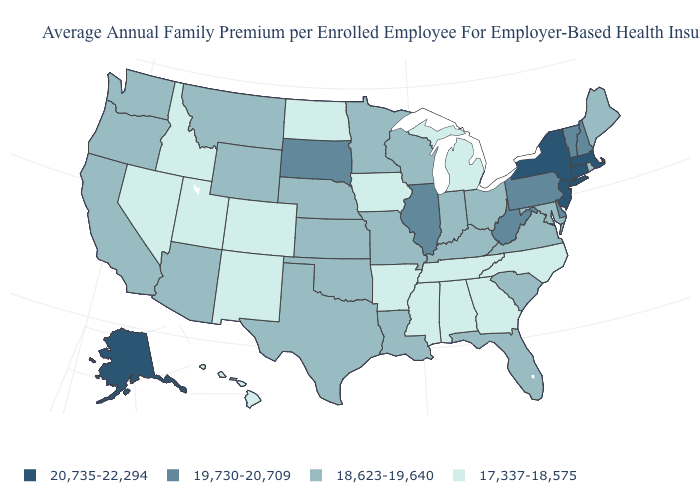Among the states that border New York , which have the highest value?
Answer briefly. Connecticut, Massachusetts, New Jersey. How many symbols are there in the legend?
Answer briefly. 4. Does the first symbol in the legend represent the smallest category?
Concise answer only. No. What is the value of Rhode Island?
Keep it brief. 18,623-19,640. Among the states that border Georgia , which have the lowest value?
Give a very brief answer. Alabama, North Carolina, Tennessee. What is the value of Arkansas?
Be succinct. 17,337-18,575. Name the states that have a value in the range 18,623-19,640?
Give a very brief answer. Arizona, California, Florida, Indiana, Kansas, Kentucky, Louisiana, Maine, Maryland, Minnesota, Missouri, Montana, Nebraska, Ohio, Oklahoma, Oregon, Rhode Island, South Carolina, Texas, Virginia, Washington, Wisconsin, Wyoming. What is the value of Virginia?
Short answer required. 18,623-19,640. Among the states that border Tennessee , which have the highest value?
Write a very short answer. Kentucky, Missouri, Virginia. What is the value of Nebraska?
Be succinct. 18,623-19,640. Does New Hampshire have the highest value in the Northeast?
Keep it brief. No. What is the value of Massachusetts?
Be succinct. 20,735-22,294. What is the value of Delaware?
Keep it brief. 19,730-20,709. Among the states that border Kansas , which have the highest value?
Be succinct. Missouri, Nebraska, Oklahoma. What is the highest value in the USA?
Write a very short answer. 20,735-22,294. 